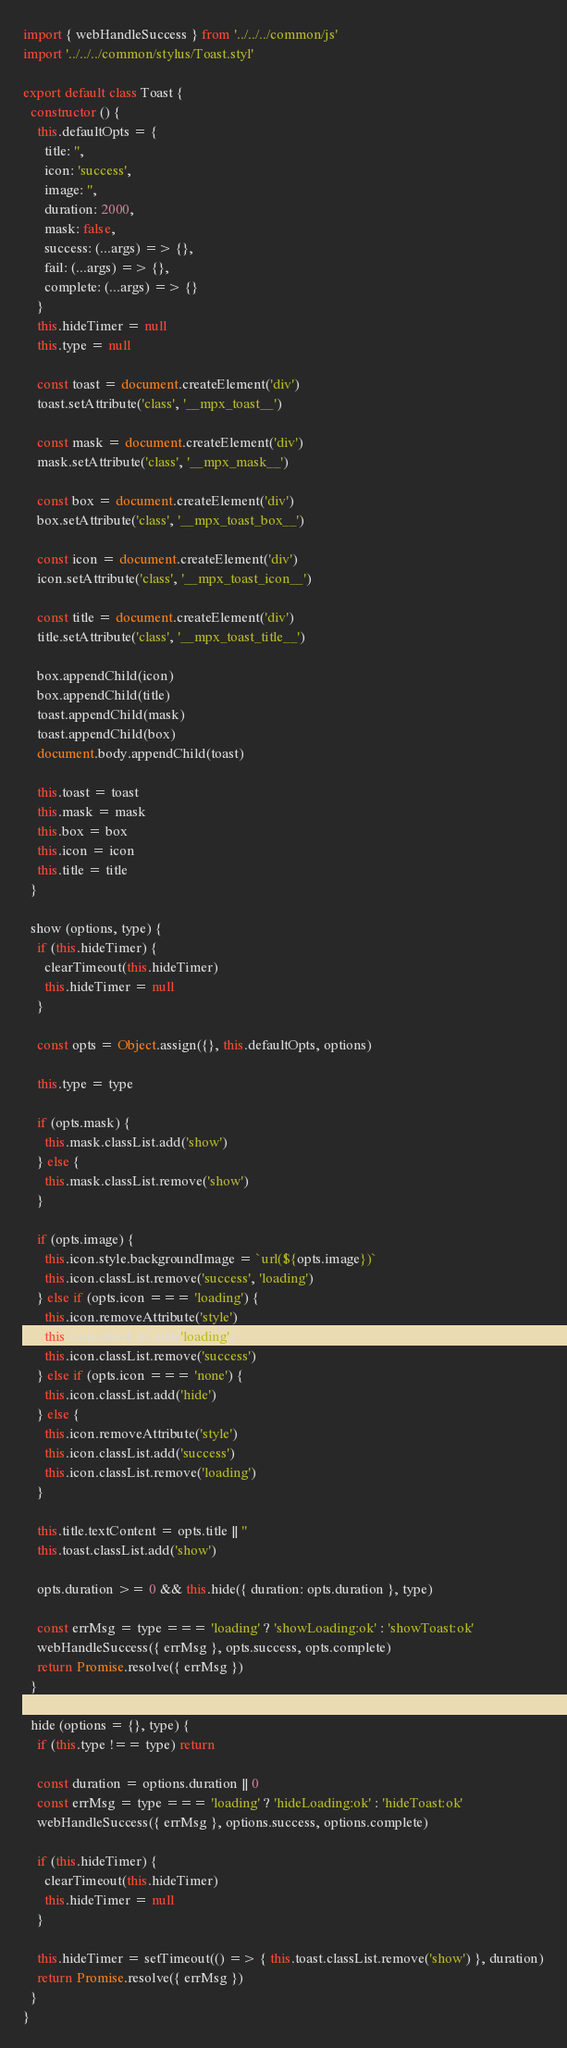<code> <loc_0><loc_0><loc_500><loc_500><_JavaScript_>import { webHandleSuccess } from '../../../common/js'
import '../../../common/stylus/Toast.styl'

export default class Toast {
  constructor () {
    this.defaultOpts = {
      title: '',
      icon: 'success',
      image: '',
      duration: 2000,
      mask: false,
      success: (...args) => {},
      fail: (...args) => {},
      complete: (...args) => {}
    }
    this.hideTimer = null
    this.type = null

    const toast = document.createElement('div')
    toast.setAttribute('class', '__mpx_toast__')

    const mask = document.createElement('div')
    mask.setAttribute('class', '__mpx_mask__')

    const box = document.createElement('div')
    box.setAttribute('class', '__mpx_toast_box__')

    const icon = document.createElement('div')
    icon.setAttribute('class', '__mpx_toast_icon__')

    const title = document.createElement('div')
    title.setAttribute('class', '__mpx_toast_title__')

    box.appendChild(icon)
    box.appendChild(title)
    toast.appendChild(mask)
    toast.appendChild(box)
    document.body.appendChild(toast)

    this.toast = toast
    this.mask = mask
    this.box = box
    this.icon = icon
    this.title = title
  }

  show (options, type) {
    if (this.hideTimer) {
      clearTimeout(this.hideTimer)
      this.hideTimer = null
    }

    const opts = Object.assign({}, this.defaultOpts, options)

    this.type = type

    if (opts.mask) {
      this.mask.classList.add('show')
    } else {
      this.mask.classList.remove('show')
    }

    if (opts.image) {
      this.icon.style.backgroundImage = `url(${opts.image})`
      this.icon.classList.remove('success', 'loading')
    } else if (opts.icon === 'loading') {
      this.icon.removeAttribute('style')
      this.icon.classList.add('loading')
      this.icon.classList.remove('success')
    } else if (opts.icon === 'none') {
      this.icon.classList.add('hide')
    } else {
      this.icon.removeAttribute('style')
      this.icon.classList.add('success')
      this.icon.classList.remove('loading')
    }

    this.title.textContent = opts.title || ''
    this.toast.classList.add('show')

    opts.duration >= 0 && this.hide({ duration: opts.duration }, type)

    const errMsg = type === 'loading' ? 'showLoading:ok' : 'showToast:ok'
    webHandleSuccess({ errMsg }, opts.success, opts.complete)
    return Promise.resolve({ errMsg })
  }

  hide (options = {}, type) {
    if (this.type !== type) return

    const duration = options.duration || 0
    const errMsg = type === 'loading' ? 'hideLoading:ok' : 'hideToast:ok'
    webHandleSuccess({ errMsg }, options.success, options.complete)

    if (this.hideTimer) {
      clearTimeout(this.hideTimer)
      this.hideTimer = null
    }

    this.hideTimer = setTimeout(() => { this.toast.classList.remove('show') }, duration)
    return Promise.resolve({ errMsg })
  }
}
</code> 